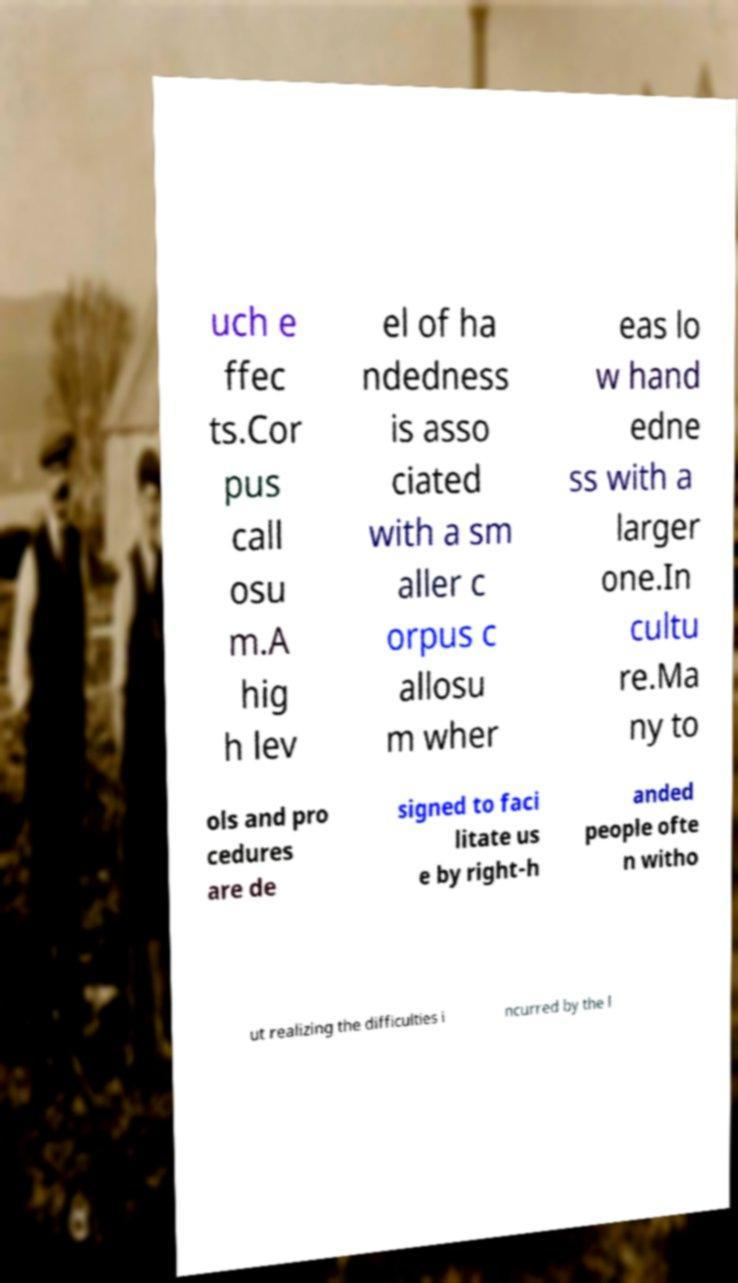Can you read and provide the text displayed in the image?This photo seems to have some interesting text. Can you extract and type it out for me? uch e ffec ts.Cor pus call osu m.A hig h lev el of ha ndedness is asso ciated with a sm aller c orpus c allosu m wher eas lo w hand edne ss with a larger one.In cultu re.Ma ny to ols and pro cedures are de signed to faci litate us e by right-h anded people ofte n witho ut realizing the difficulties i ncurred by the l 